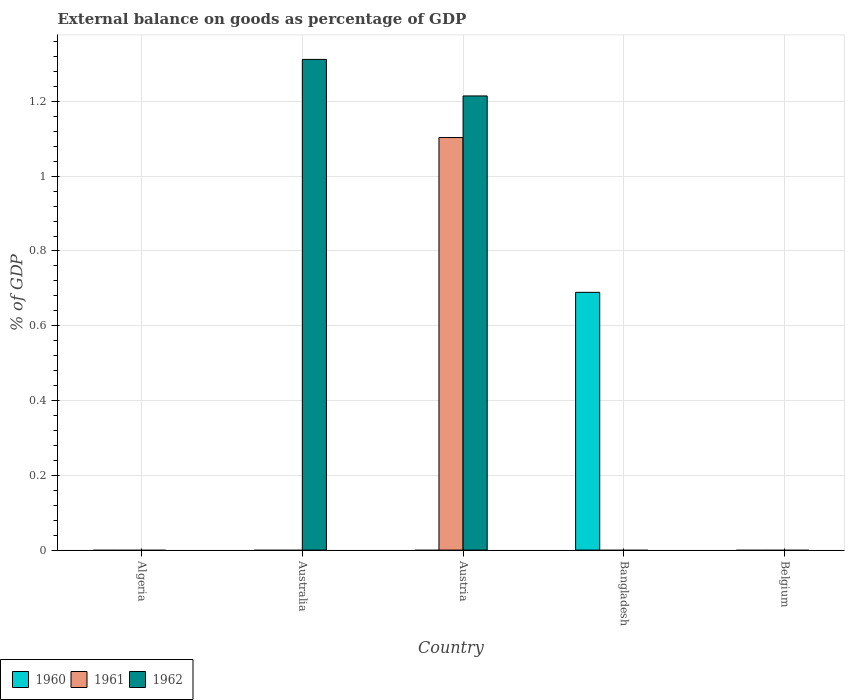How many bars are there on the 5th tick from the right?
Offer a terse response. 0. What is the label of the 5th group of bars from the left?
Your response must be concise. Belgium. In how many cases, is the number of bars for a given country not equal to the number of legend labels?
Your response must be concise. 5. Across all countries, what is the maximum external balance on goods as percentage of GDP in 1960?
Your response must be concise. 0.69. In which country was the external balance on goods as percentage of GDP in 1962 maximum?
Your response must be concise. Australia. What is the total external balance on goods as percentage of GDP in 1962 in the graph?
Make the answer very short. 2.53. What is the difference between the external balance on goods as percentage of GDP in 1962 in Australia and that in Austria?
Make the answer very short. 0.1. What is the difference between the external balance on goods as percentage of GDP in 1962 in Bangladesh and the external balance on goods as percentage of GDP in 1961 in Austria?
Offer a terse response. -1.1. What is the average external balance on goods as percentage of GDP in 1960 per country?
Offer a terse response. 0.14. What is the difference between the highest and the lowest external balance on goods as percentage of GDP in 1962?
Your response must be concise. 1.31. Are all the bars in the graph horizontal?
Offer a very short reply. No. What is the difference between two consecutive major ticks on the Y-axis?
Make the answer very short. 0.2. Are the values on the major ticks of Y-axis written in scientific E-notation?
Provide a short and direct response. No. Where does the legend appear in the graph?
Keep it short and to the point. Bottom left. How many legend labels are there?
Your answer should be very brief. 3. What is the title of the graph?
Make the answer very short. External balance on goods as percentage of GDP. Does "1995" appear as one of the legend labels in the graph?
Ensure brevity in your answer.  No. What is the label or title of the Y-axis?
Your answer should be compact. % of GDP. What is the % of GDP in 1960 in Algeria?
Provide a succinct answer. 0. What is the % of GDP in 1962 in Australia?
Make the answer very short. 1.31. What is the % of GDP in 1961 in Austria?
Provide a short and direct response. 1.1. What is the % of GDP of 1962 in Austria?
Ensure brevity in your answer.  1.21. What is the % of GDP in 1960 in Bangladesh?
Provide a succinct answer. 0.69. What is the % of GDP in 1962 in Bangladesh?
Your answer should be compact. 0. What is the % of GDP of 1961 in Belgium?
Give a very brief answer. 0. Across all countries, what is the maximum % of GDP in 1960?
Make the answer very short. 0.69. Across all countries, what is the maximum % of GDP in 1961?
Provide a short and direct response. 1.1. Across all countries, what is the maximum % of GDP in 1962?
Offer a very short reply. 1.31. Across all countries, what is the minimum % of GDP of 1961?
Offer a very short reply. 0. Across all countries, what is the minimum % of GDP in 1962?
Your answer should be very brief. 0. What is the total % of GDP in 1960 in the graph?
Ensure brevity in your answer.  0.69. What is the total % of GDP in 1961 in the graph?
Offer a very short reply. 1.1. What is the total % of GDP of 1962 in the graph?
Provide a short and direct response. 2.53. What is the difference between the % of GDP of 1962 in Australia and that in Austria?
Make the answer very short. 0.1. What is the average % of GDP of 1960 per country?
Make the answer very short. 0.14. What is the average % of GDP of 1961 per country?
Make the answer very short. 0.22. What is the average % of GDP in 1962 per country?
Provide a succinct answer. 0.51. What is the difference between the % of GDP in 1961 and % of GDP in 1962 in Austria?
Keep it short and to the point. -0.11. What is the ratio of the % of GDP in 1962 in Australia to that in Austria?
Your answer should be compact. 1.08. What is the difference between the highest and the lowest % of GDP of 1960?
Offer a very short reply. 0.69. What is the difference between the highest and the lowest % of GDP of 1961?
Make the answer very short. 1.1. What is the difference between the highest and the lowest % of GDP of 1962?
Ensure brevity in your answer.  1.31. 